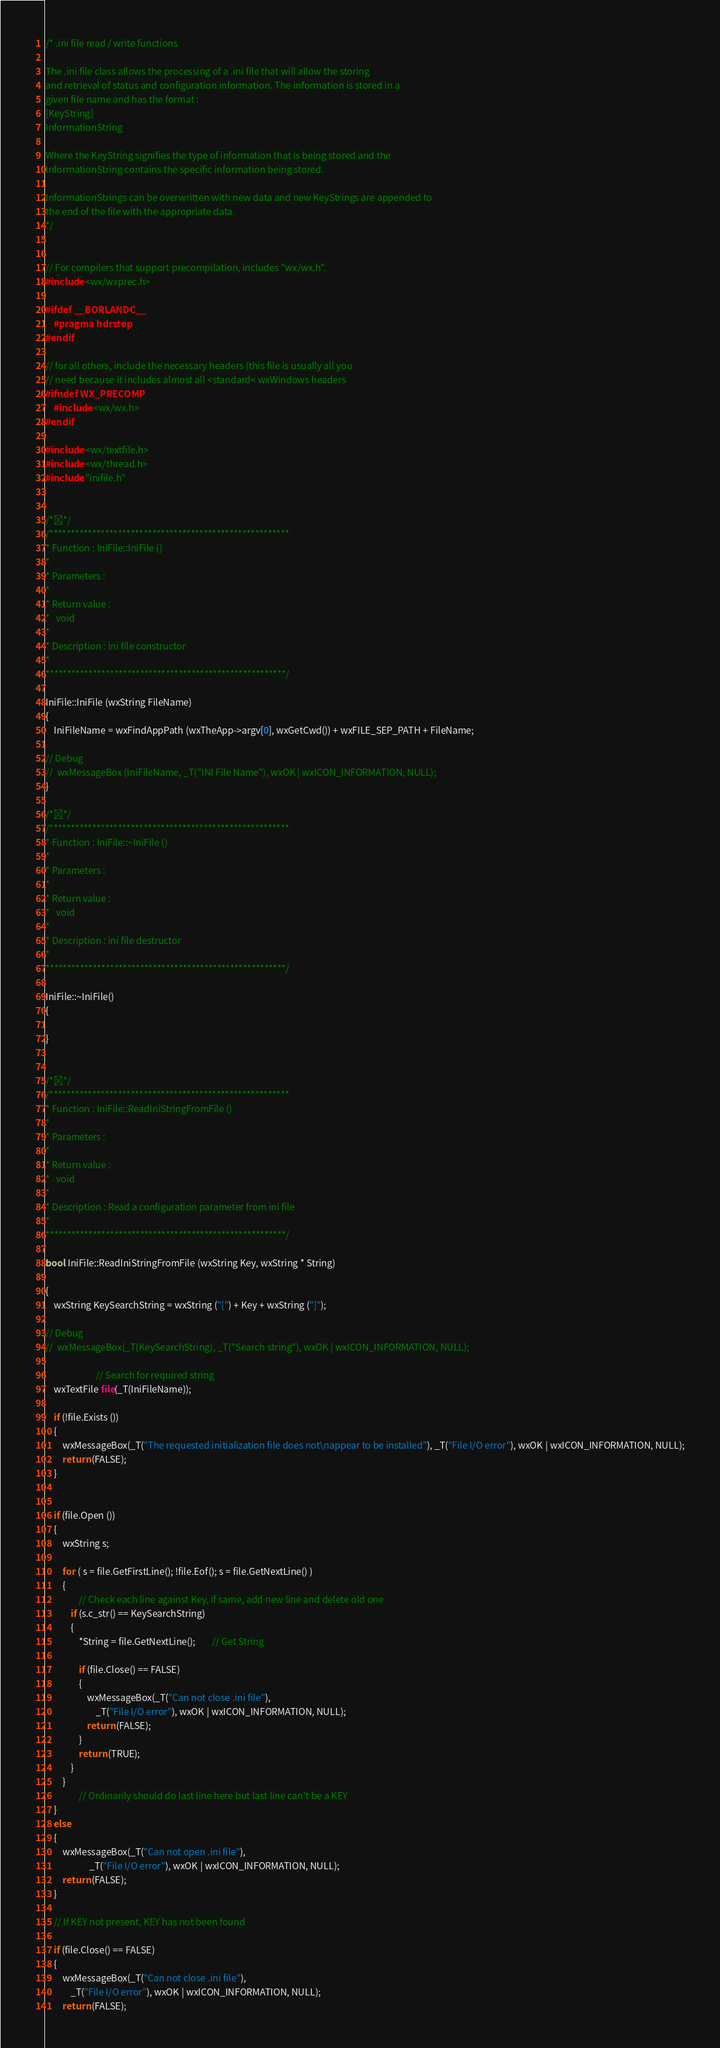Convert code to text. <code><loc_0><loc_0><loc_500><loc_500><_C++_>/* .ini file read / write functions

The .ini file class allows the processing of a .ini file that will allow the storing
and retrieval of status and configuration information. The information is stored in a
given file name and has the format :
[KeyString]
InformationString

Where the KeyString signifies the type of information that is being stored and the
InformationString contains the specific information being stored.

InformationStrings can be overwritten with new data and new KeyStrings are appended to
the end of the file with the appropriate data.
*/


// For compilers that support precompilation, includes "wx/wx.h".
#include <wx/wxprec.h>

#ifdef __BORLANDC__
	#pragma hdrstop
#endif

// for all others, include the necessary headers (this file is usually all you
// need because it includes almost all <standard< wxWindows headers
#ifndef WX_PRECOMP
	#include <wx/wx.h>
#endif

#include <wx/textfile.h>
#include <wx/thread.h>
#include "inifile.h"


/**/
/********************************************************
* Function : IniFile::IniFile ()
*
* Parameters :
*
* Return value :
*	void
*
* Description : ini file constructor
*
********************************************************/

IniFile::IniFile (wxString FileName)
{
	IniFileName = wxFindAppPath (wxTheApp->argv[0], wxGetCwd()) + wxFILE_SEP_PATH + FileName;

// Debug
//	wxMessageBox (IniFileName, _T("INI File Name"), wxOK | wxICON_INFORMATION, NULL);
}

/**/
/********************************************************
* Function : IniFile::~IniFile ()
*
* Parameters :
*
* Return value :
*	void
*
* Description : ini file destructor
*
********************************************************/

IniFile::~IniFile()
{

}


/**/
/********************************************************
* Function : IniFile::ReadIniStringFromFile ()
*
* Parameters :
*
* Return value :
*	void
*
* Description : Read a configuration parameter from ini file
*
********************************************************/

bool IniFile::ReadIniStringFromFile (wxString Key, wxString * String)

{
	wxString KeySearchString = wxString ("[") + Key + wxString ("]");

// Debug
//	wxMessageBox(_T(KeySearchString), _T("Search string"), wxOK | wxICON_INFORMATION, NULL);

						// Search for required string
	wxTextFile file(_T(IniFileName));

	if (!file.Exists ())
	{
		wxMessageBox(_T("The requested initialization file does not\nappear to be installed"), _T("File I/O error"), wxOK | wxICON_INFORMATION, NULL);
		return (FALSE);         
	}


	if (file.Open ())
	{
		wxString s;

		for ( s = file.GetFirstLine(); !file.Eof(); s = file.GetNextLine() )
		{
				// Check each line against Key, if same, add new line and delete old one
			if (s.c_str() == KeySearchString)
			{
				*String = file.GetNextLine();		// Get String

				if (file.Close() == FALSE)
				{
					wxMessageBox(_T("Can not close .ini file"),
						_T("File I/O error"), wxOK | wxICON_INFORMATION, NULL);
					return (FALSE);         
				}
				return (TRUE);
			}
		}
				// Ordinarily should do last line here but last line can't be a KEY
	}
	else
	{
		wxMessageBox(_T("Can not open .ini file"),
					 _T("File I/O error"), wxOK | wxICON_INFORMATION, NULL);
		return (FALSE);
	}

	// If KEY not present, KEY has not been found

	if (file.Close() == FALSE)
	{
		wxMessageBox(_T("Can not close .ini file"),
			_T("File I/O error"), wxOK | wxICON_INFORMATION, NULL);
		return (FALSE);         </code> 